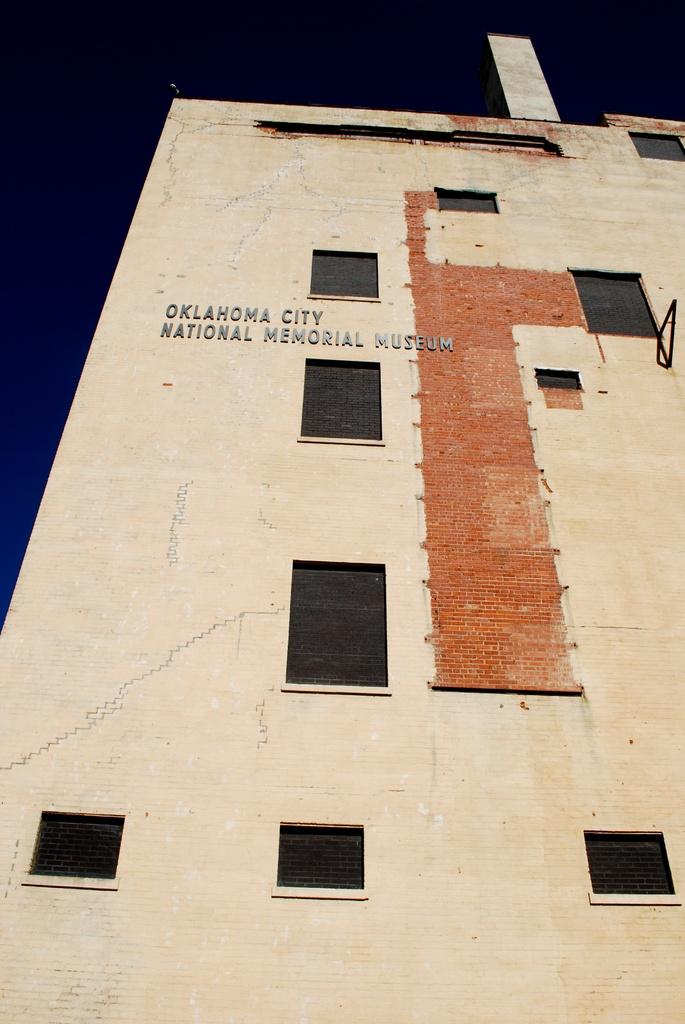What type of structure is present in the image? There is a building in the image. Can you describe the appearance of the top of the building? The top of the building appears to be dark. What feature is visible on the building? There are windows visible on the building. Is there any text or information about the building in the image? Yes, the name of the building is mentioned in the image. Can you tell me how many candles are on the birthday cake in the image? There is no birthday cake present in the image; it features a building with windows and a dark top. 